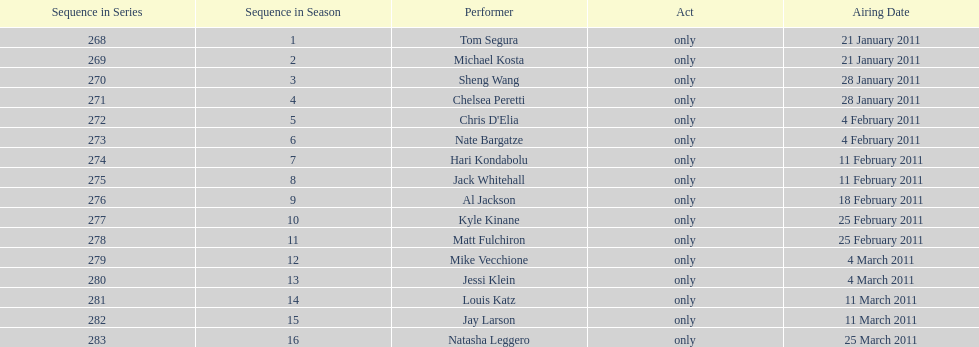How many weeks did season 15 of comedy central presents span? 9. 